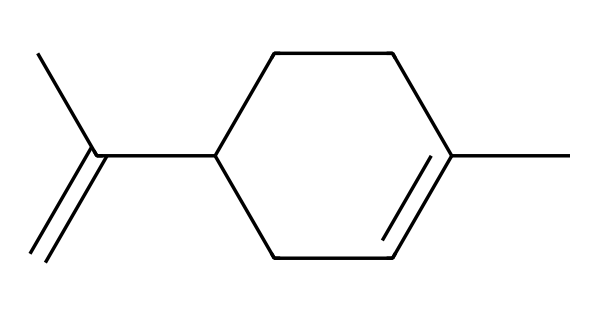What is the molecular formula of limonene? To find the molecular formula, count the number of each type of atom in the SMILES representation (C and H). The structure shows 10 carbon atoms and 16 hydrogen atoms, resulting in the formula C10H16.
Answer: C10H16 How many rings are present in this structure? The given structure is a cycloalkane, which by definition has one or more rings. This structure contains one ring as indicated by the "C1" notation in the SMILES, implying the formation of a cyclic structure.
Answer: 1 What type of chemical is limonene specifically classified as? Limonene is classified as a terpenoid because it is a hydrocarbon derived from isoprene units and has a cyclic structure. The presence of the ring and its chemical composition confirms this classification.
Answer: terpenoid How many double bonds does limonene contain? By analyzing the structure derived from the SMILES, there are two double bonds present indicated by the "=" signs within the structure, making it a compound with unsaturation.
Answer: 2 Which functional groups are present in the limonene molecule? The primary functional group present in limonene is the alkene due to the presence of the double bonds in the structure. No other functional groups like hydroxyl or carbonyl are present in this representation.
Answer: alkene What is the significance of limonene in nature? Limonene is significant in nature because it is commonly found in the essential oils of citrus fruits, contributing to their fragrance. Its presence in Islamic texts highlights its cultural and medicinal importance as well.
Answer: fragrance 